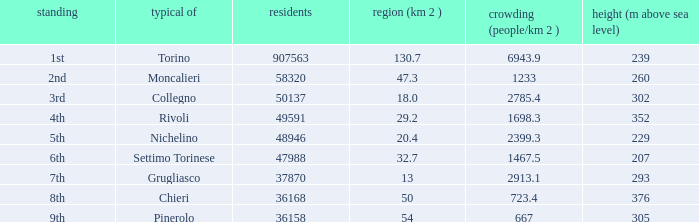How many population statistics are presented for settimo torinese? 1.0. 